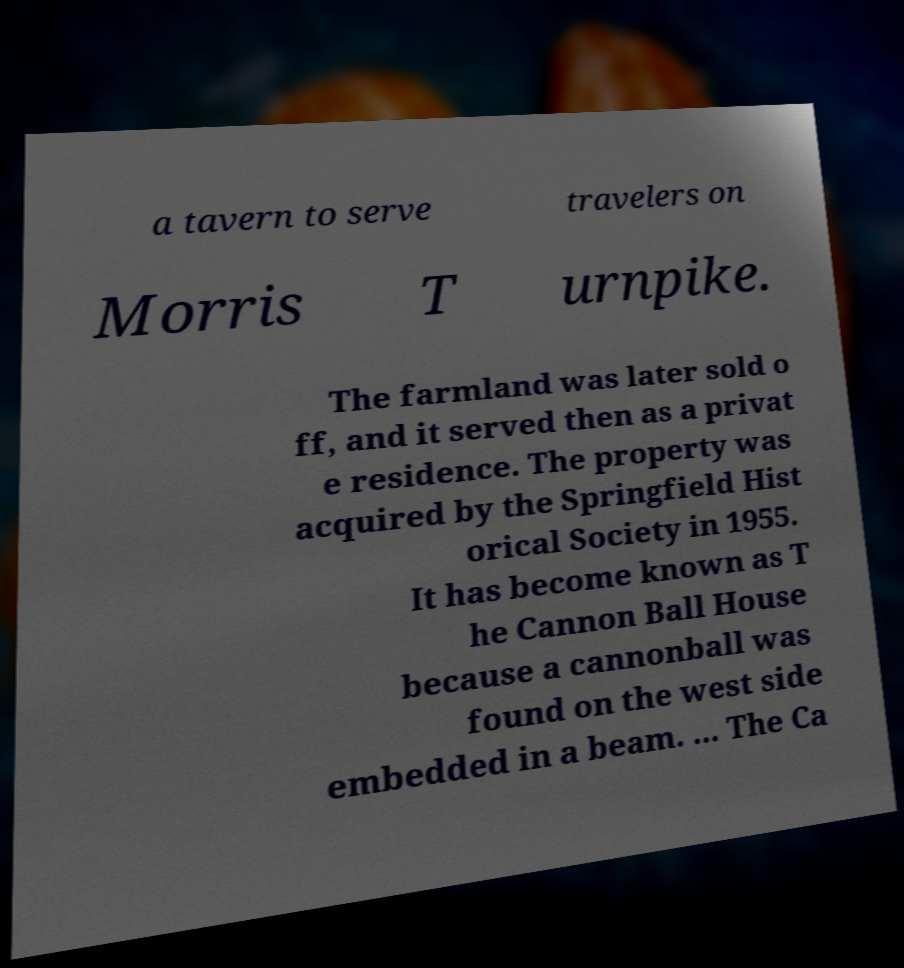Could you extract and type out the text from this image? a tavern to serve travelers on Morris T urnpike. The farmland was later sold o ff, and it served then as a privat e residence. The property was acquired by the Springfield Hist orical Society in 1955. It has become known as T he Cannon Ball House because a cannonball was found on the west side embedded in a beam. ... The Ca 